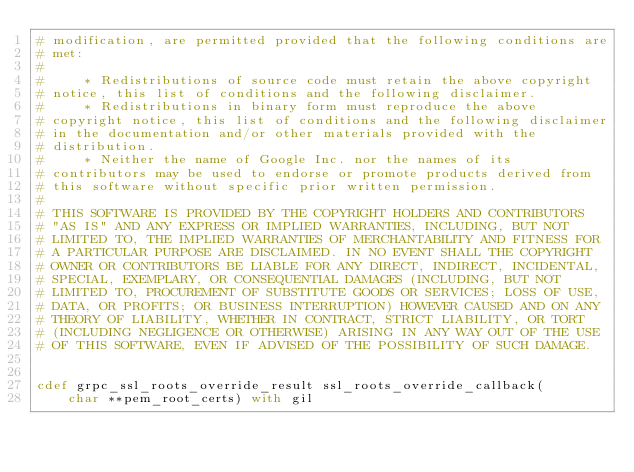Convert code to text. <code><loc_0><loc_0><loc_500><loc_500><_Cython_># modification, are permitted provided that the following conditions are
# met:
#
#     * Redistributions of source code must retain the above copyright
# notice, this list of conditions and the following disclaimer.
#     * Redistributions in binary form must reproduce the above
# copyright notice, this list of conditions and the following disclaimer
# in the documentation and/or other materials provided with the
# distribution.
#     * Neither the name of Google Inc. nor the names of its
# contributors may be used to endorse or promote products derived from
# this software without specific prior written permission.
#
# THIS SOFTWARE IS PROVIDED BY THE COPYRIGHT HOLDERS AND CONTRIBUTORS
# "AS IS" AND ANY EXPRESS OR IMPLIED WARRANTIES, INCLUDING, BUT NOT
# LIMITED TO, THE IMPLIED WARRANTIES OF MERCHANTABILITY AND FITNESS FOR
# A PARTICULAR PURPOSE ARE DISCLAIMED. IN NO EVENT SHALL THE COPYRIGHT
# OWNER OR CONTRIBUTORS BE LIABLE FOR ANY DIRECT, INDIRECT, INCIDENTAL,
# SPECIAL, EXEMPLARY, OR CONSEQUENTIAL DAMAGES (INCLUDING, BUT NOT
# LIMITED TO, PROCUREMENT OF SUBSTITUTE GOODS OR SERVICES; LOSS OF USE,
# DATA, OR PROFITS; OR BUSINESS INTERRUPTION) HOWEVER CAUSED AND ON ANY
# THEORY OF LIABILITY, WHETHER IN CONTRACT, STRICT LIABILITY, OR TORT
# (INCLUDING NEGLIGENCE OR OTHERWISE) ARISING IN ANY WAY OUT OF THE USE
# OF THIS SOFTWARE, EVEN IF ADVISED OF THE POSSIBILITY OF SUCH DAMAGE.


cdef grpc_ssl_roots_override_result ssl_roots_override_callback(
    char **pem_root_certs) with gil
</code> 